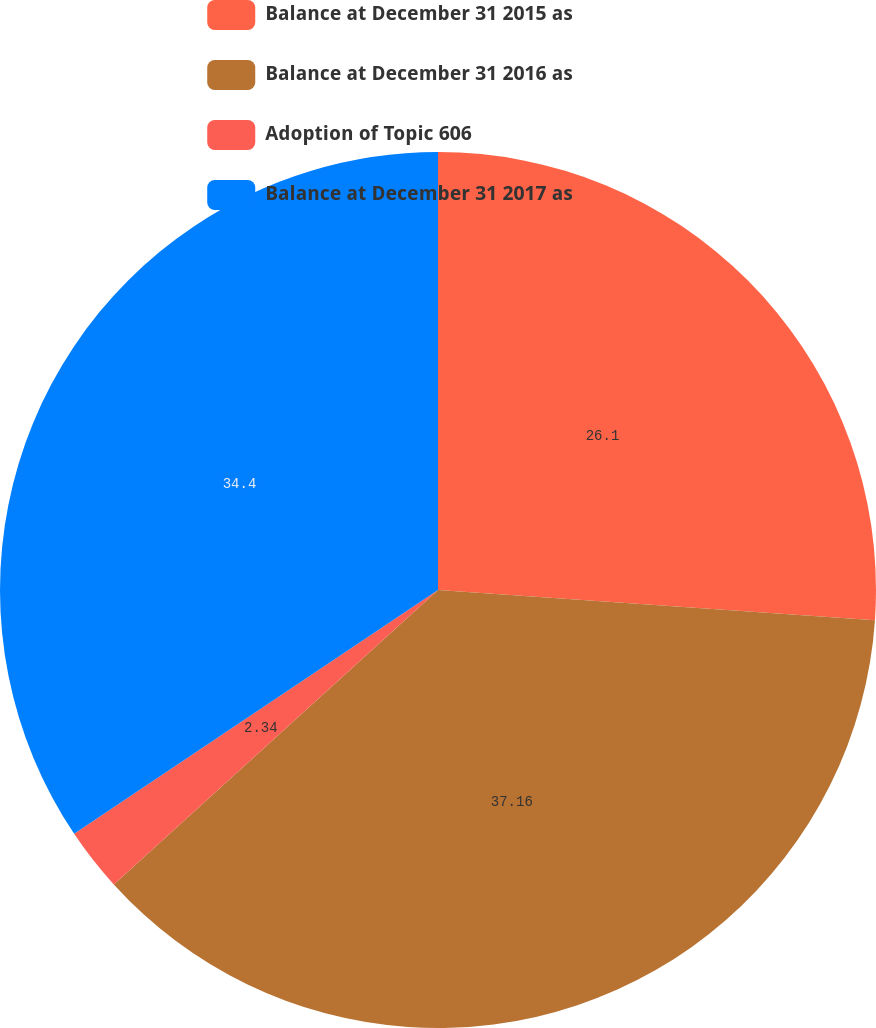<chart> <loc_0><loc_0><loc_500><loc_500><pie_chart><fcel>Balance at December 31 2015 as<fcel>Balance at December 31 2016 as<fcel>Adoption of Topic 606<fcel>Balance at December 31 2017 as<nl><fcel>26.1%<fcel>37.17%<fcel>2.34%<fcel>34.4%<nl></chart> 